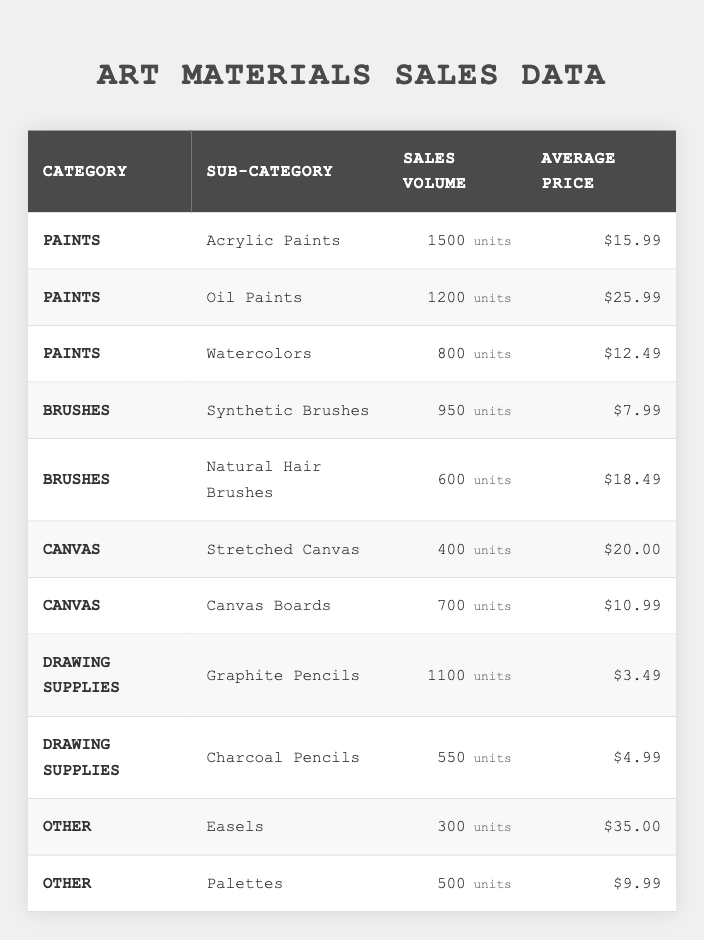What is the total sales volume of Paints? To find the total sales volume of Paints, we sum the sales volumes for all subcategories under Paints: 1500 (Acrylic) + 1200 (Oil) + 800 (Watercolors) = 3500.
Answer: 3500 Which sub-category has the highest average price? The average prices from the table are: Acrylic Paints - $15.99, Oil Paints - $25.99, Watercolors - $12.49, Synthetic Brushes - $7.99, Natural Hair Brushes - $18.49, Stretched Canvas - $20.00, Canvas Boards - $10.99, Graphite Pencils - $3.49, Charcoal Pencils - $4.99, Easels - $35.00, Palettes - $9.99. The highest is $35.00 for Easels.
Answer: Easels How many units of Natural Hair Brushes were sold? The table shows that 600 units of Natural Hair Brushes were sold.
Answer: 600 What is the average sales volume across all subcategories? To find the average sales volume, we add all sales volumes: 1500 + 1200 + 800 + 950 + 600 + 400 + 700 + 1100 + 550 + 300 + 500 =  8100. There are 11 subcategories, so the average is 8100 / 11 ≈ 736.36.
Answer: 736.36 Is the sales volume of Canvas Boards greater than that of Stretched Canvas? The sales volume of Canvas Boards is 700 and that of Stretched Canvas is 400. Since 700 > 400, the statement is true.
Answer: Yes What is the total revenue generated from sales of Oil Paints? The revenue is calculated by multiplying the sales volume by the average price: 1200 units * $25.99 = $31,188.
Answer: $31,188 What is the total sales volume of Brushes? To calculate the total sales volume of Brushes, we sum the sales volumes of all subcategories under Brushes: 950 (Synthetic) + 600 (Natural Hair) = 1550.
Answer: 1550 Which materials had a sales volume of less than 500 units? From the table, the subcategories with sales volumes less than 500 are: Easels (300) and Stretched Canvas (400).
Answer: Easels and Stretched Canvas What is the combined average price of Painting materials (Acrylic, Oil, Watercolors)? The average price for these Paints is calculated as follows: (15.99 + 25.99 + 12.49) / 3 = 18.16.
Answer: 18.16 How many units of Drawing Supplies were sold in total? The sales volumes for Drawing Supplies are 1100 (Graphite Pencils) and 550 (Charcoal Pencils). Adding them gives 1100 + 550 = 1650.
Answer: 1650 